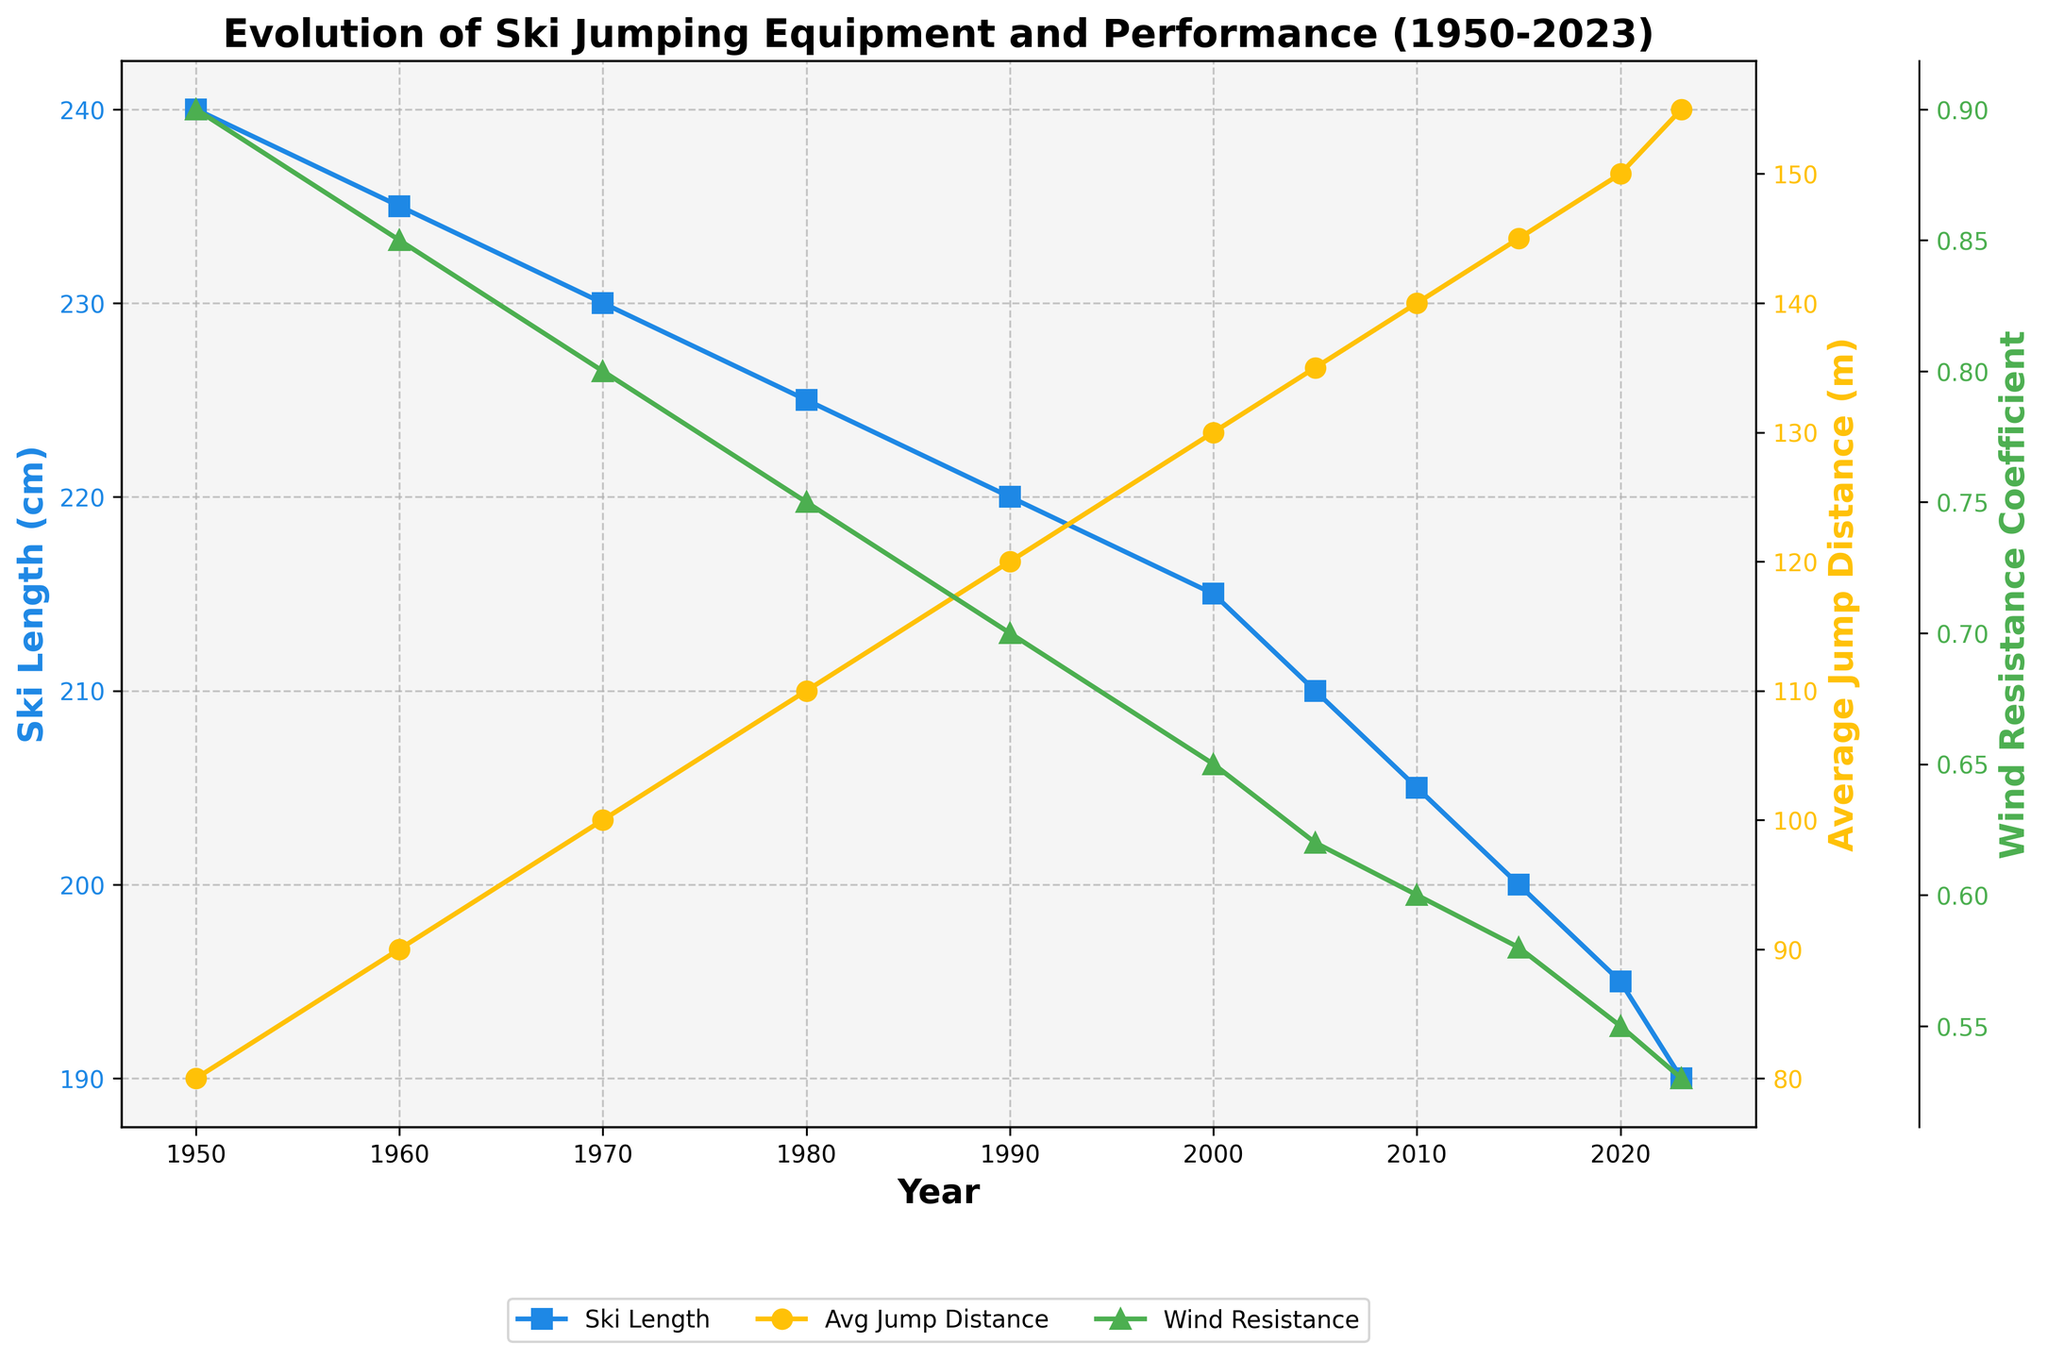What is the trend in ski length from 1950 to 2023? Ski length consistently decreases over the years. It starts at 240 cm in 1950 and drops to 190 cm in 2023.
Answer: Decreasing How does the average jump distance change from 1950 to 2023? The average jump distance increases significantly from 80 meters in 1950 to 155 meters in 2023.
Answer: Increasing What is the relationship between ski length and average jump distance? As ski length decreases over the years, the average jump distance increases. This inverse relationship suggests that shorter skis might contribute to longer jump distances.
Answer: Inverse relationship By how much did the average jump distance increase between 1980 and 2023? Average jump distance in 1980 was 110 meters and in 2023 it is 155 meters. The increase is 155 - 110 = 45 meters.
Answer: 45 meters Which year experienced the biggest drop in wind resistance coefficient? Wind resistance coefficient drops steadily, but the largest single drop is from 1990 to 2000, decreasing by 0.05 units (from 0.7 to 0.65).
Answer: 1990-2000 What is the difference in ski length between 1960 and 2023? Ski length in 1960 is 235 cm, and in 2023 it is 190 cm. The difference is 235 - 190 = 45 cm.
Answer: 45 cm In which year did the binding release force exceed 300 N for the first time? Binding release force exceeds 300 N in the year 1990, reaching exactly 300 N.
Answer: 1990 Comparing the year 2000 to 2023, which factors saw an increase and which saw a decrease? From 2000 to 2023, ski length decreased from 215 cm to 190 cm, average jump distance increased from 130 m to 155 m, and wind resistance coefficient decreased from 0.65 to 0.53.
Answer: Ski length decreased, average jump distance increased, wind resistance decreased How did the wind resistance coefficient influence the average jump distance? As the wind resistance coefficient decreases from 0.9 in 1950 to 0.53 in 2023, the average jump distance increases from 80 meters to 155 meters. This suggests a negative correlation where lower wind resistance may contribute to longer jumps.
Answer: Negative correlation By what percentage did the wind resistance coefficient decrease from 1950 to 2023? The wind resistance coefficient in 1950 was 0.9 and in 2023 it is 0.53. The percentage decrease is ((0.9 - 0.53) / 0.9) * 100 = 41.1%.
Answer: 41.1% 